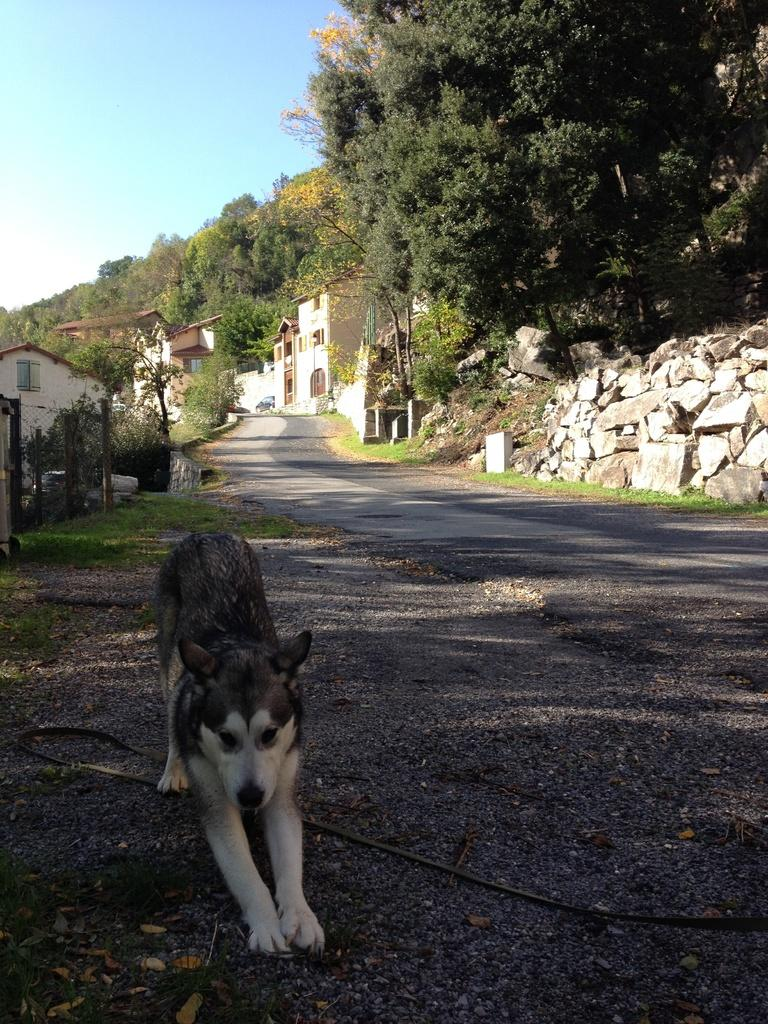What animal can be seen in the picture? There is a dog in the picture. What type of environment is visible in the backdrop? There are buildings, rocks, a road, and trees in the backdrop. What is the condition of the sky in the picture? The sky is clear in the picture. What company is located in the downtown area shown in the image? There is no downtown area or company mentioned in the image; it features a dog and a backdrop with various elements. 